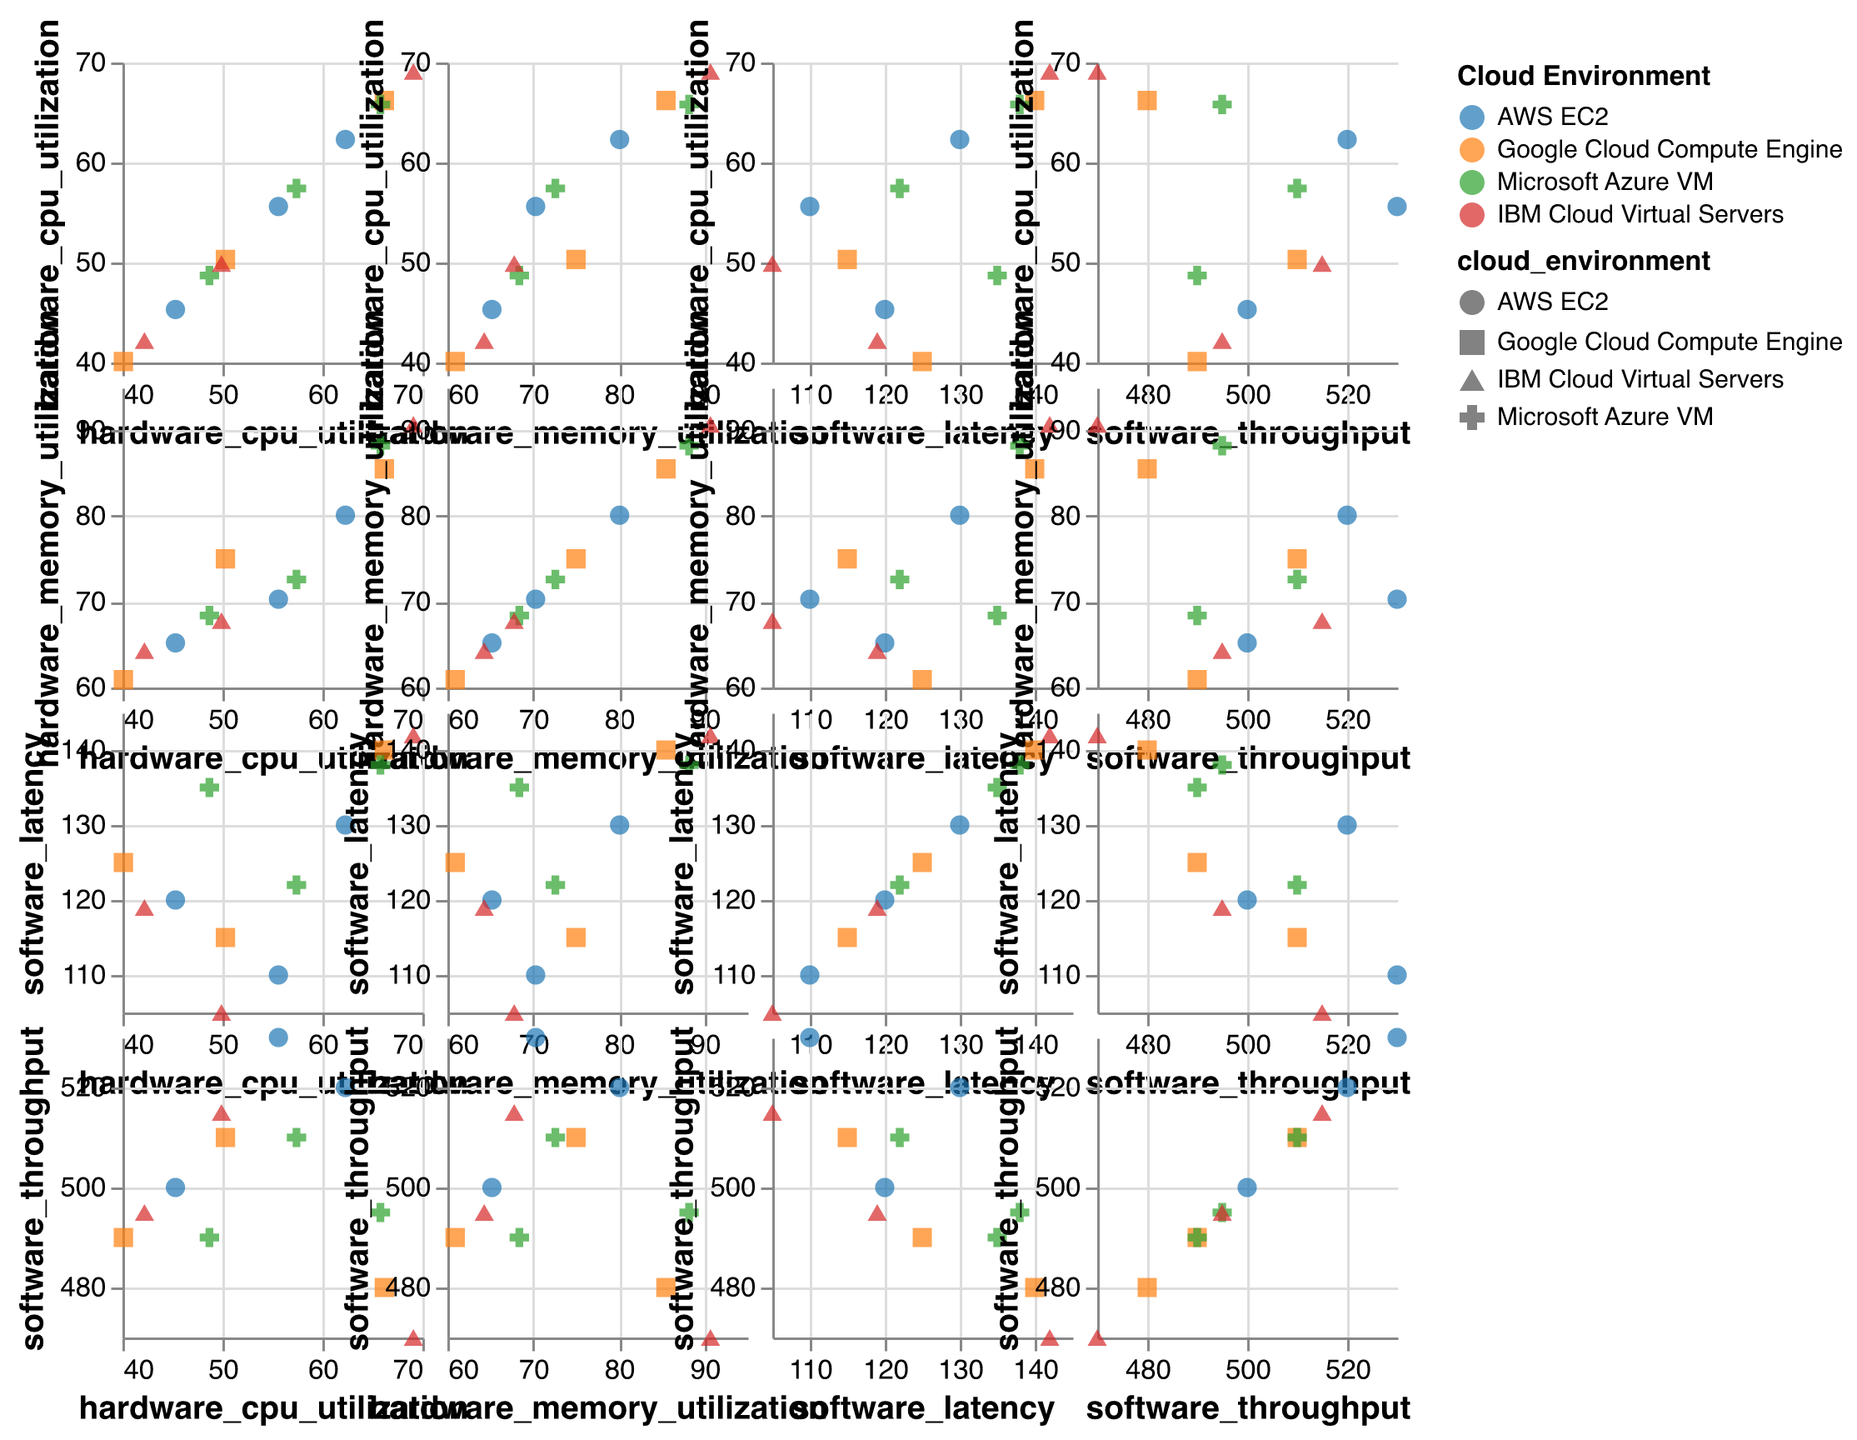How many distinct cloud environments are represented in the chart? The chart uses different colors and shapes for distinct cloud environments, which are specified in the legend. Counting these categories gives the number of distinct cloud environments.
Answer: 4 Which cloud environment appears to have the highest range in CPU utilization? By examining the range of CPU utilization values for each cloud environment in the scatter plots, Microsoft Azure VM shows the highest range from about 48.7 to 65.8.
Answer: Microsoft Azure VM Is there a general trend between CPU utilization and software latency for most cloud environments? By looking at the scatter plots relating CPU utilization to software latency across different cloud environments, most environments show an increasing trend in latency with higher CPU utilization.
Answer: Increasing trend What is the approximate range of software latency for Google Cloud Compute Engine? Observing the scatter plots involving software latency for Google Cloud Compute Engine, the latency values range approximately from 115 to 140.
Answer: 115 to 140 Which cloud environment has the lowest observed hardware memory utilization? By finding the lowest hardware memory utilization point on the scatter plots for each cloud environment, Google Cloud Compute Engine shows the lowest at around 60.9.
Answer: Google Cloud Compute Engine Do higher throughputs often correspond to lower latencies in the data points? By inspecting the subplots that relate software throughput and software latency, higher throughputs often seem correlated with lower latencies, noticeable across most cloud environments.
Answer: Yes How does IBM Cloud Virtual Servers compare to AWS EC2 in terms of maximum memory utilization? Checking the scatter plots for the highest memory utilization points, IBM Cloud Virtual Servers has a higher maximum (about 90.7) compared to AWS EC2 (around 80.1).
Answer: IBM Cloud Virtual Servers is higher What general trend can be observed between hardware memory utilization and software throughput? By analyzing the scatter plots between hardware memory utilization and software throughput, there is a tendency for throughput to drop as memory utilization increases, seen across multiple cloud environments.
Answer: Throughput decreases with higher memory utilization Which cloud environment has the highest observed latency? Finding the maximum data point in the scatter plots related to latency across all cloud environments, IBM Cloud Virtual Servers shows the highest observed latency at 142.
Answer: IBM Cloud Virtual Servers Are there any cloud environments where a higher CPU utilization does not correlate with increased latency? Comparing the scatter plots of CPU utilization vs. software latency for anomalies, Google Cloud Compute Engine exhibits a few cases where higher CPU utilization does not correlate proportionally with latency increases.
Answer: Google Cloud Compute Engine 